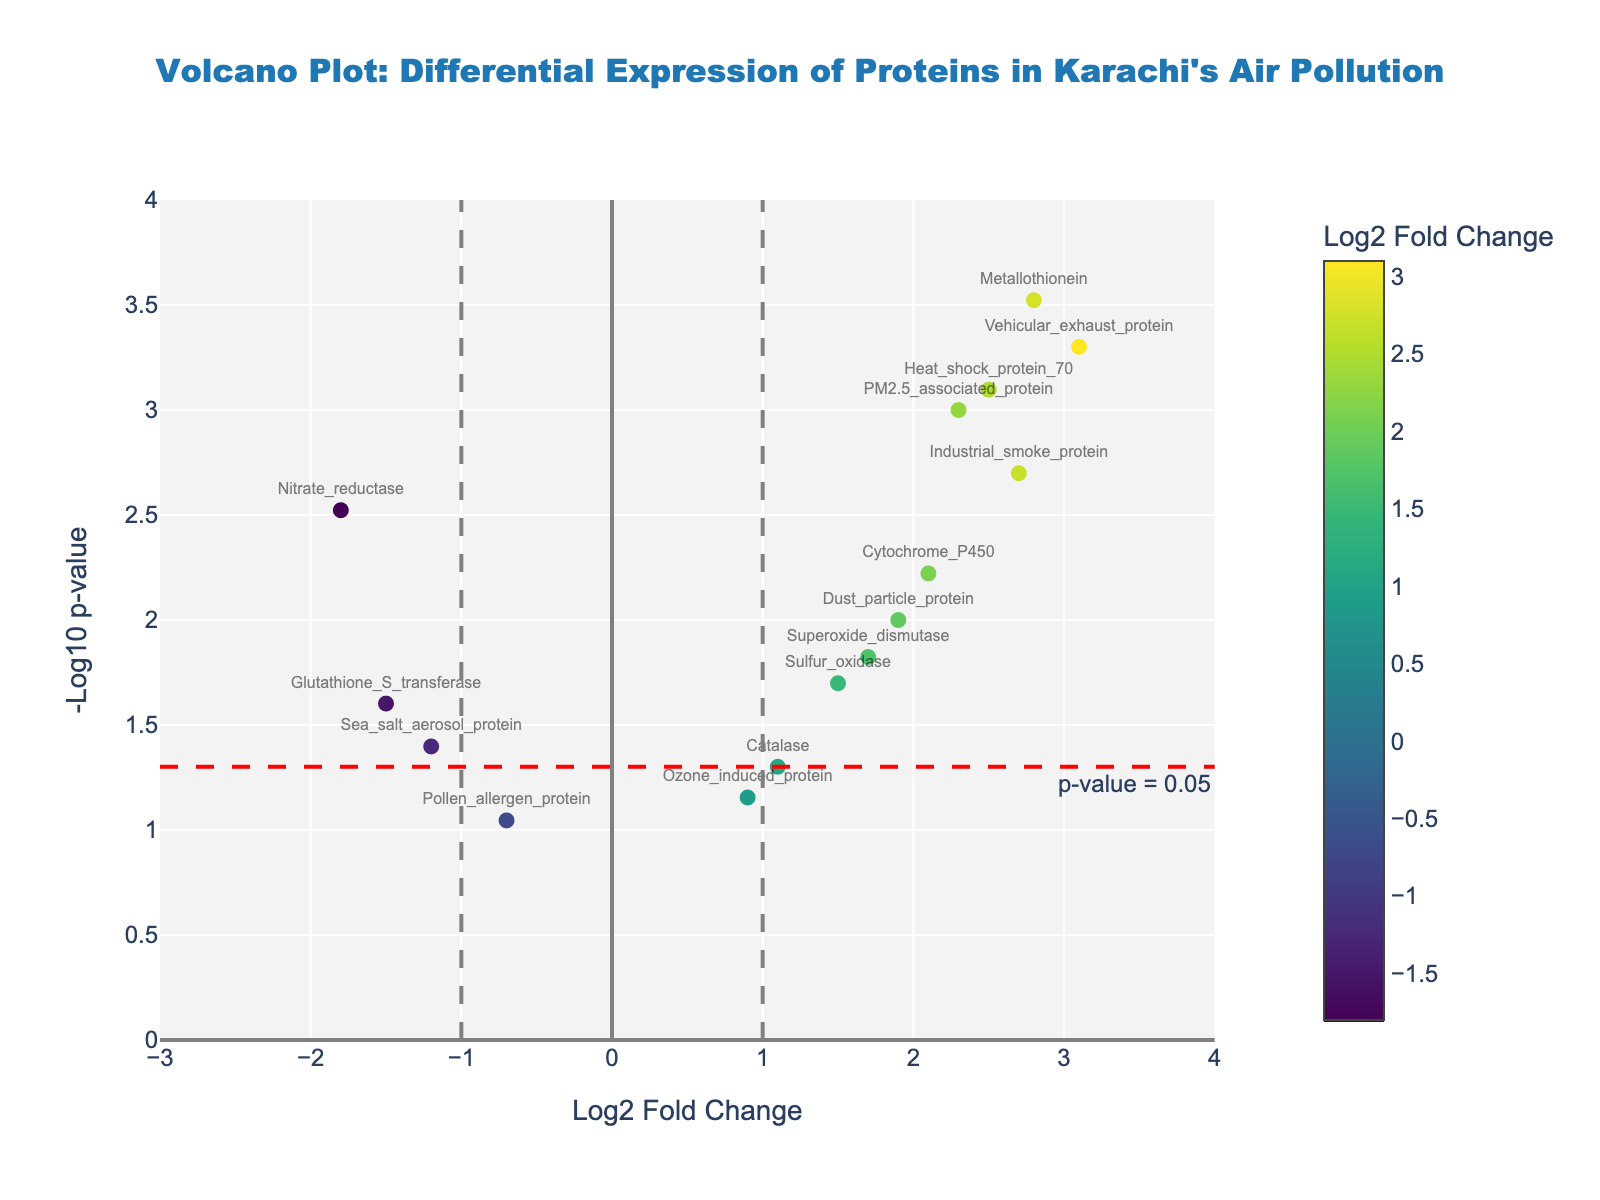What is the title of the plot? The title of the plot is centrally located at the top of the figure and reads, "Volcano Plot: Differential Expression of Proteins in Karachi's Air Pollution".
Answer: Volcano Plot: Differential Expression of Proteins in Karachi's Air Pollution What do the x and y axes represent? The x-axis represents "Log2 Fold Change" and the y-axis represents "-Log10 p-value". These labels are located at the bottom and left side of the plot, respectively.
Answer: Log2 Fold Change and -Log10 p-value How many proteins have a p-value less than 0.05? We use the horizontal red line annotated with "p-value = 0.05" as a threshold. Any protein above this line has a p-value less than 0.05. There are 10 data points above this line.
Answer: 10 Which protein has the highest log2 fold change and what is its value? The protein with the highest log2 fold change is the point farthest to the right on the x-axis. It is "Vehicular_exhaust_protein" with a log2 fold change of 3.1.
Answer: Vehicular_exhaust_protein with 3.1 Name two proteins with negative log2 fold changes but significant p-values (< 0.05). To find proteins with negative log2 fold changes and p-values below 0.05, look for proteins left of the vertical grey line at x=-1 and above the horizontal red line. These proteins are "Nitrate_reductase" and "Glutathione_S_transferase".
Answer: Nitrate_reductase and Glutathione_S_transferase Which proteins are closest to the origin of the plot and what are their characteristics? The proteins closest to the origin (0,0) are those with points near the intersection of the x and y axes. "Pollen_allergen_protein" and "Ozone_induced_protein" are closest, with log2 fold changes near zero and p-values indicating non-significance (values around 0.09 and 0.07 respectively).
Answer: Pollen_allergen_protein and Ozone_induced_protein Which protein has the smallest p-value and how is it represented in the plot? The protein with the smallest p-value appears highest on the y-axis because of the -log10 transformation. "Metallothionein" has the smallest p-value of 0.0003 and is thus the topmost point on the plot.
Answer: Metallothionein How many proteins have a log2 fold change greater than 1? Proteins with log2 fold changes greater than 1 are to the right of the vertical grey line at x=1. Count all points to the right of this line, which are 7 in total.
Answer: 7 Which protein lies exactly on the vertical line at log2 fold change = 1 and what is its significance? The protein that lies on the vertical grey line at log2 fold change = 1 can be identified by the point directly on this line. This protein is "Catalase" and its placement on the edge of the significant change threshold is notable.
Answer: Catalase 